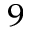<formula> <loc_0><loc_0><loc_500><loc_500>^ { 9 }</formula> 